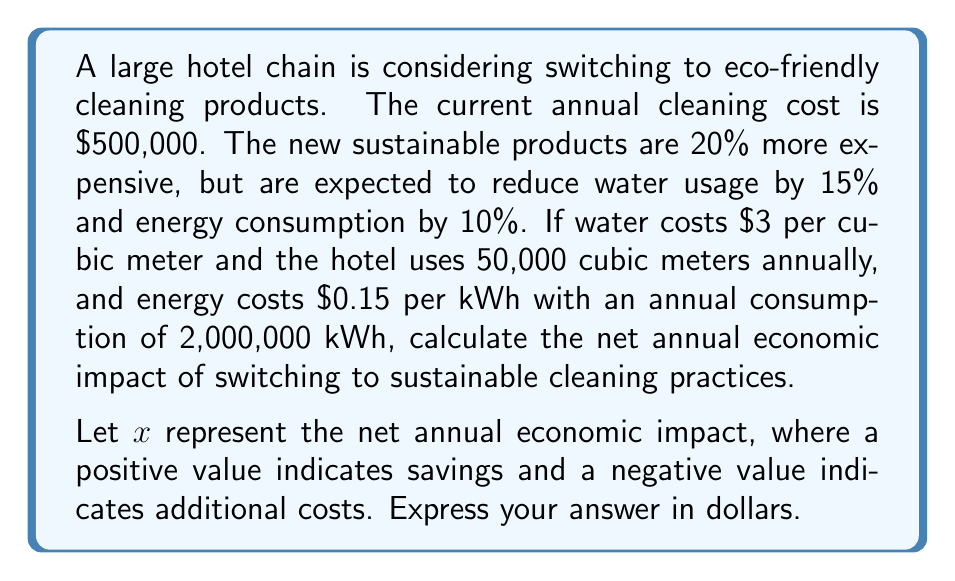Can you answer this question? To solve this problem, we need to calculate the changes in costs for cleaning products, water, and energy, then sum them up to find the net impact.

1. Change in cleaning product costs:
   Current cost = $500,000
   New cost = $500,000 * 1.20 = $600,000
   Increase in cost = $600,000 - $500,000 = $100,000

2. Change in water costs:
   Current water usage = 50,000 cubic meters
   New water usage = 50,000 * (1 - 0.15) = 42,500 cubic meters
   Water savings = (50,000 - 42,500) * $3 = 7,500 * $3 = $22,500

3. Change in energy costs:
   Current energy usage = 2,000,000 kWh
   New energy usage = 2,000,000 * (1 - 0.10) = 1,800,000 kWh
   Energy savings = (2,000,000 - 1,800,000) * $0.15 = 200,000 * $0.15 = $30,000

4. Net annual economic impact:
   $x = -\text{Increase in cleaning product costs} + \text{Water savings} + \text{Energy savings}$
   $x = -100,000 + 22,500 + 30,000$
   $x = -47,500$

The negative value indicates that switching to sustainable cleaning practices will result in an additional annual cost of $47,500.
Answer: $x = -$47,500 